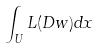Convert formula to latex. <formula><loc_0><loc_0><loc_500><loc_500>\int _ { U } L ( D w ) d x</formula> 